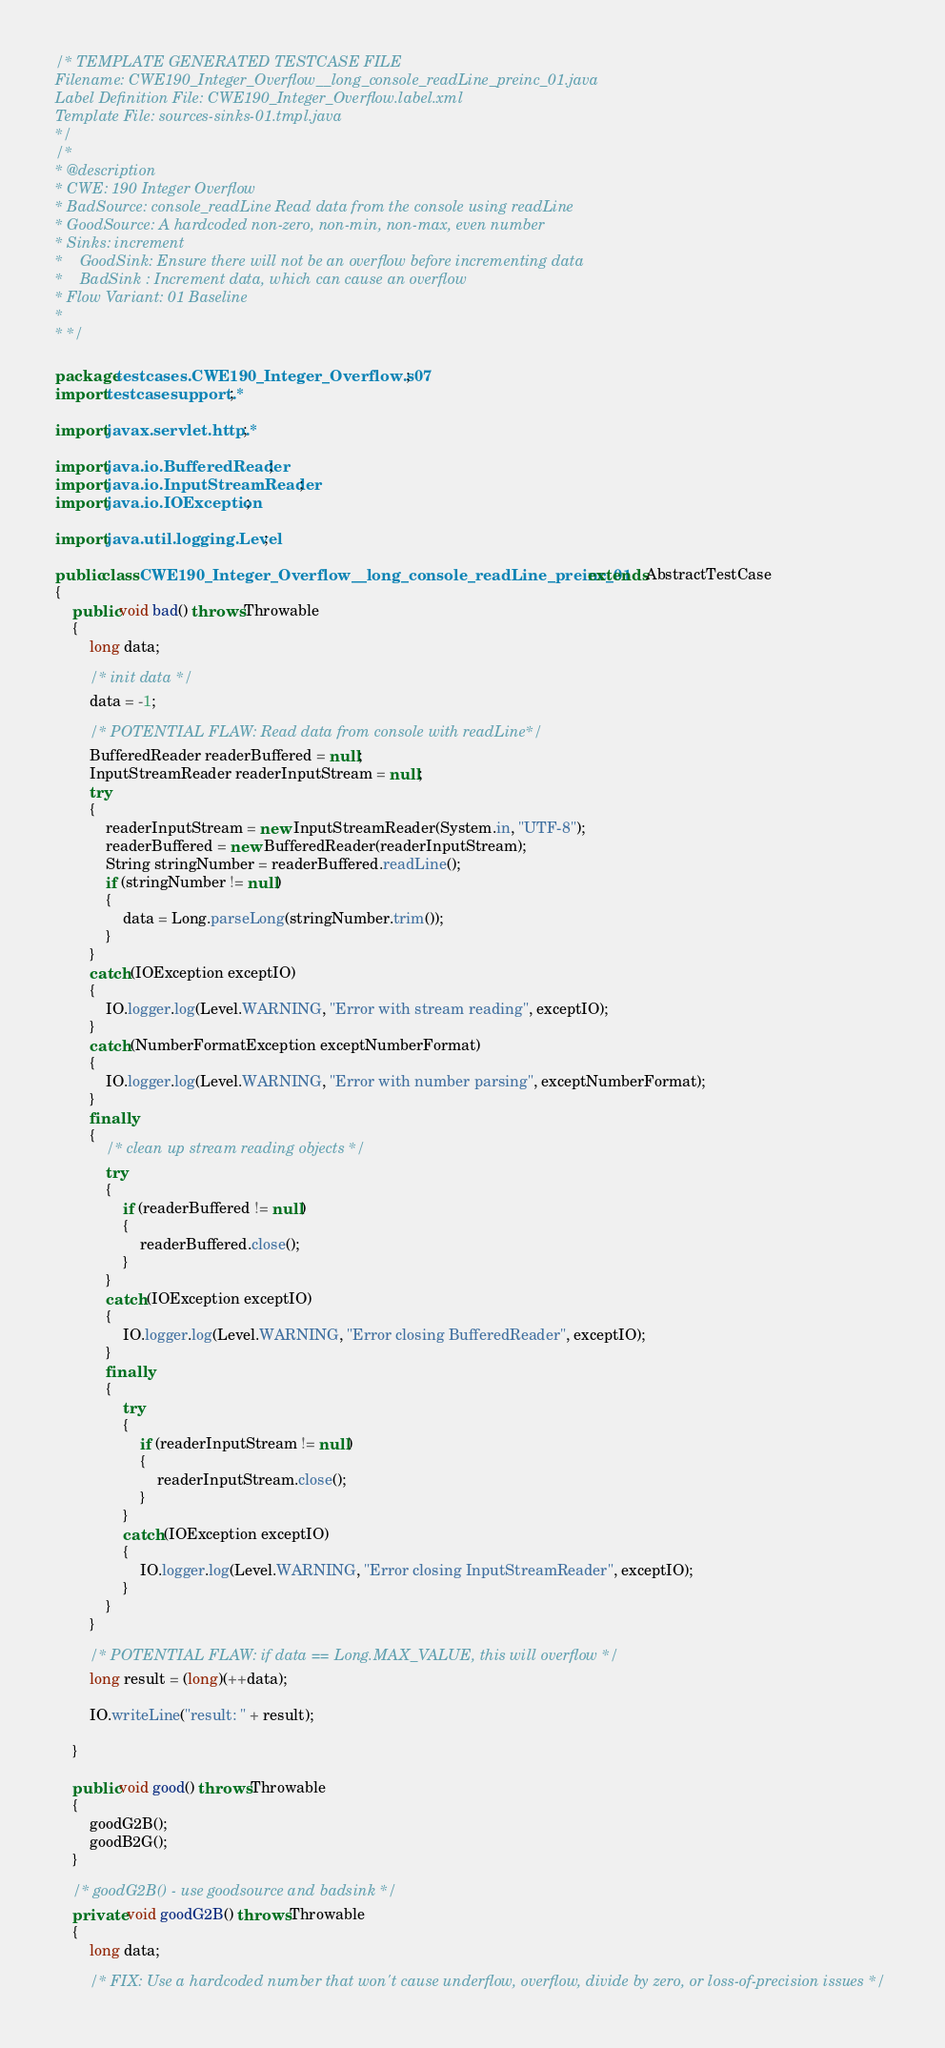Convert code to text. <code><loc_0><loc_0><loc_500><loc_500><_Java_>/* TEMPLATE GENERATED TESTCASE FILE
Filename: CWE190_Integer_Overflow__long_console_readLine_preinc_01.java
Label Definition File: CWE190_Integer_Overflow.label.xml
Template File: sources-sinks-01.tmpl.java
*/
/*
* @description
* CWE: 190 Integer Overflow
* BadSource: console_readLine Read data from the console using readLine
* GoodSource: A hardcoded non-zero, non-min, non-max, even number
* Sinks: increment
*    GoodSink: Ensure there will not be an overflow before incrementing data
*    BadSink : Increment data, which can cause an overflow
* Flow Variant: 01 Baseline
*
* */

package testcases.CWE190_Integer_Overflow.s07;
import testcasesupport.*;

import javax.servlet.http.*;

import java.io.BufferedReader;
import java.io.InputStreamReader;
import java.io.IOException;

import java.util.logging.Level;

public class CWE190_Integer_Overflow__long_console_readLine_preinc_01 extends AbstractTestCase
{
    public void bad() throws Throwable
    {
        long data;

        /* init data */
        data = -1;

        /* POTENTIAL FLAW: Read data from console with readLine*/
        BufferedReader readerBuffered = null;
        InputStreamReader readerInputStream = null;
        try
        {
            readerInputStream = new InputStreamReader(System.in, "UTF-8");
            readerBuffered = new BufferedReader(readerInputStream);
            String stringNumber = readerBuffered.readLine();
            if (stringNumber != null)
            {
                data = Long.parseLong(stringNumber.trim());
            }
        }
        catch (IOException exceptIO)
        {
            IO.logger.log(Level.WARNING, "Error with stream reading", exceptIO);
        }
        catch (NumberFormatException exceptNumberFormat)
        {
            IO.logger.log(Level.WARNING, "Error with number parsing", exceptNumberFormat);
        }
        finally
        {
            /* clean up stream reading objects */
            try
            {
                if (readerBuffered != null)
                {
                    readerBuffered.close();
                }
            }
            catch (IOException exceptIO)
            {
                IO.logger.log(Level.WARNING, "Error closing BufferedReader", exceptIO);
            }
            finally
            {
                try
                {
                    if (readerInputStream != null)
                    {
                        readerInputStream.close();
                    }
                }
                catch (IOException exceptIO)
                {
                    IO.logger.log(Level.WARNING, "Error closing InputStreamReader", exceptIO);
                }
            }
        }

        /* POTENTIAL FLAW: if data == Long.MAX_VALUE, this will overflow */
        long result = (long)(++data);

        IO.writeLine("result: " + result);

    }

    public void good() throws Throwable
    {
        goodG2B();
        goodB2G();
    }

    /* goodG2B() - use goodsource and badsink */
    private void goodG2B() throws Throwable
    {
        long data;

        /* FIX: Use a hardcoded number that won't cause underflow, overflow, divide by zero, or loss-of-precision issues */</code> 